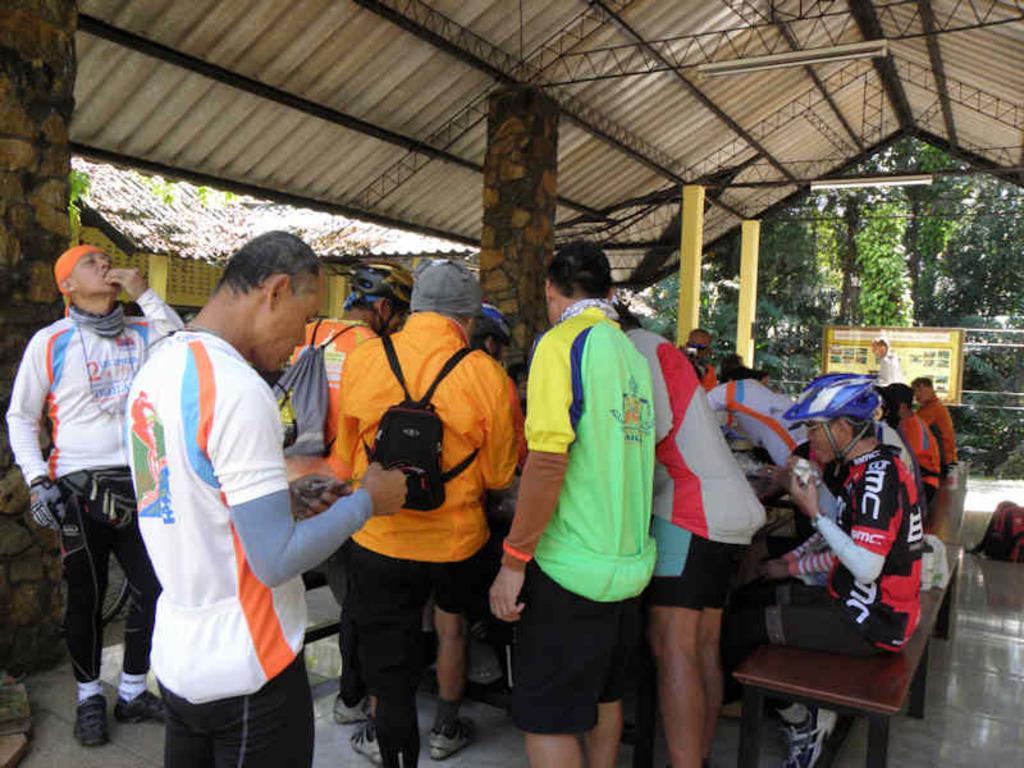Describe this image in one or two sentences. In this image I can see few people and few people are sitting. They are wearing different color dress and few are wearing bags. Back I can see a building,shed,trees,board. 